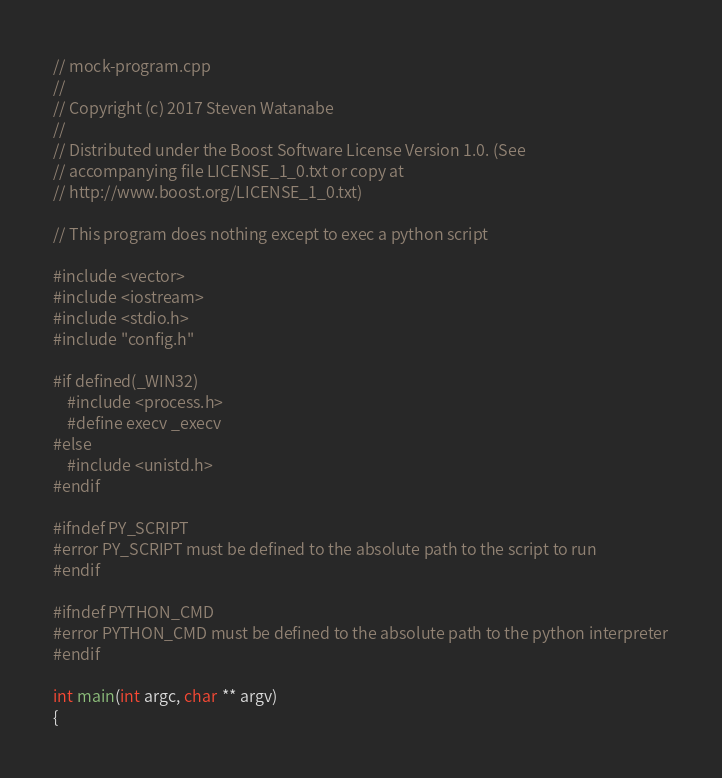<code> <loc_0><loc_0><loc_500><loc_500><_C++_>// mock-program.cpp
//
// Copyright (c) 2017 Steven Watanabe
//
// Distributed under the Boost Software License Version 1.0. (See
// accompanying file LICENSE_1_0.txt or copy at
// http://www.boost.org/LICENSE_1_0.txt)

// This program does nothing except to exec a python script

#include <vector>
#include <iostream>
#include <stdio.h>
#include "config.h"

#if defined(_WIN32)
    #include <process.h>
    #define execv _execv
#else
    #include <unistd.h>
#endif

#ifndef PY_SCRIPT
#error PY_SCRIPT must be defined to the absolute path to the script to run
#endif

#ifndef PYTHON_CMD
#error PYTHON_CMD must be defined to the absolute path to the python interpreter
#endif

int main(int argc, char ** argv)
{</code> 